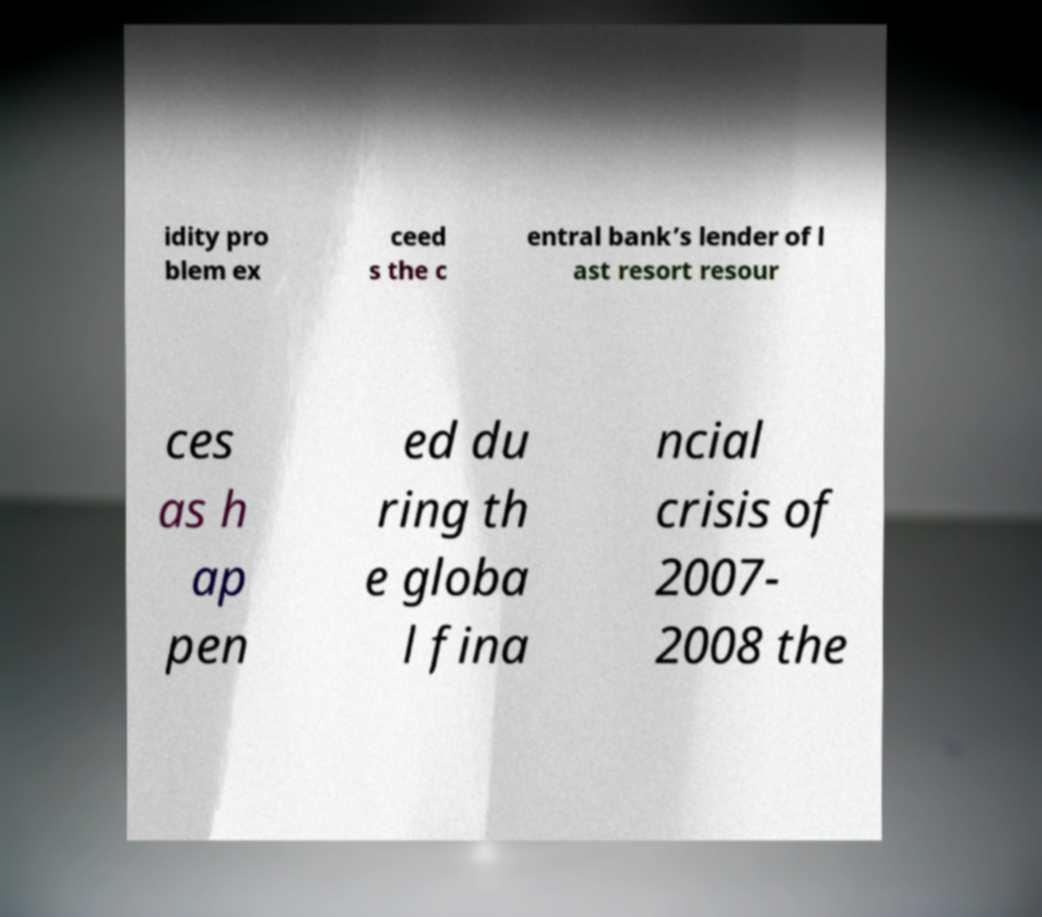There's text embedded in this image that I need extracted. Can you transcribe it verbatim? idity pro blem ex ceed s the c entral bank’s lender of l ast resort resour ces as h ap pen ed du ring th e globa l fina ncial crisis of 2007- 2008 the 